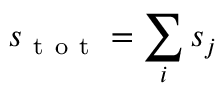Convert formula to latex. <formula><loc_0><loc_0><loc_500><loc_500>s _ { t o t } = \sum _ { i } s _ { j }</formula> 